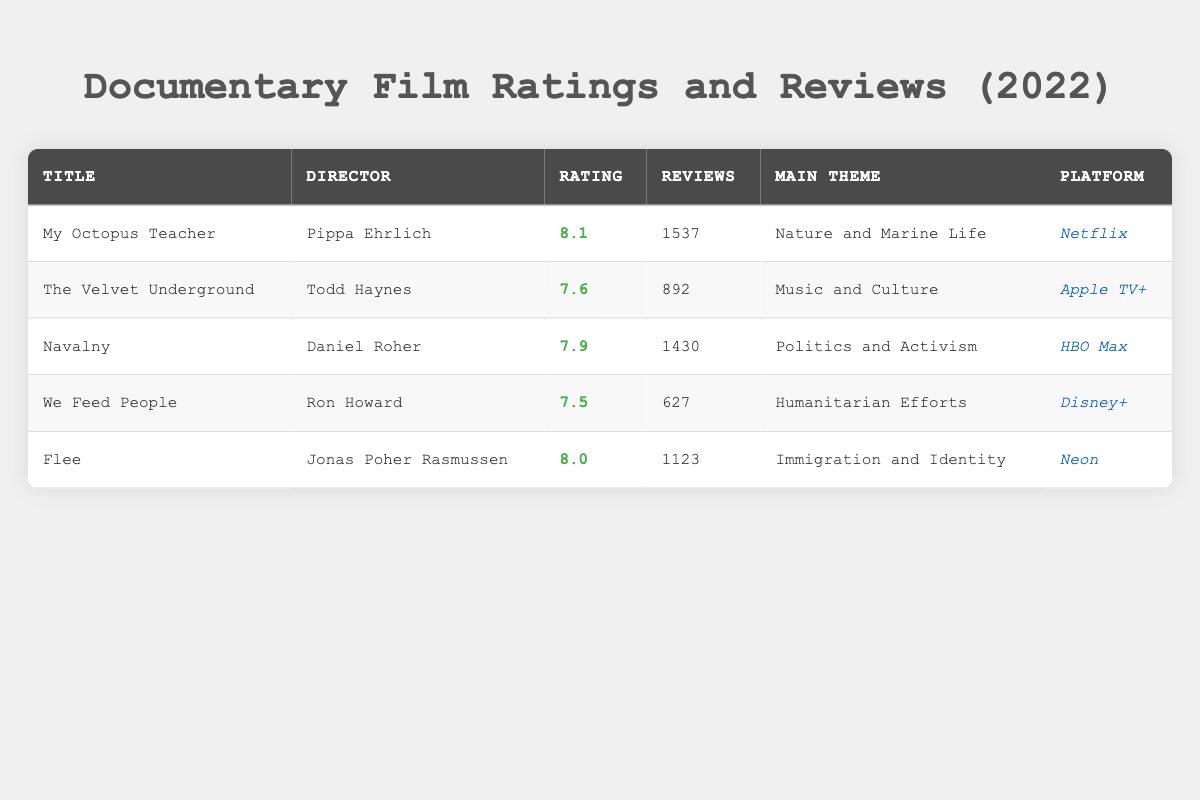What is the highest rated documentary in 2022 according to the table? The table lists several documentaries with their ratings. By checking the ratings, "My Octopus Teacher" has the highest rating of 8.1.
Answer: My Octopus Teacher How many reviews did Flee receive? The title "Flee" has 1123 reviews listed in the table.
Answer: 1123 Which documentary has the main theme of "Politics and Activism"? By looking at the table, we can see that "Navalny" has the main theme of "Politics and Activism."
Answer: Navalny What is the average rating of the documentaries listed? To find the average rating, sum the ratings: 8.1 + 7.6 + 7.9 + 7.5 + 8.0 = 39.1. There are 5 documentaries, so the average rating is 39.1 / 5 = 7.82.
Answer: 7.82 Is there a documentary directed by Pippa Ehrlich? The table shows that "My Octopus Teacher" is directed by Pippa Ehrlich. Therefore, the answer is yes.
Answer: Yes Which platform has the least number of reviews for its documentary? Looking at the reviews counts of each documentary: Netflix (1537), Apple TV+ (892), HBO Max (1430), Disney+ (627), and Neon (1123). The least is 627, which is on Disney+.
Answer: Disney+ How many documentaries have a rating of 8.0 or higher? The documentaries with ratings of 8.0 or higher are "My Octopus Teacher" (8.1) and "Flee" (8.0). Adding these, there are 2 documentaries in total.
Answer: 2 What is the total number of reviews across all documentaries? Adding the reviews together: 1537 + 892 + 1430 + 627 + 1123 = 4609. This is the total number of reviews for all documentaries listed.
Answer: 4609 Is "We Feed People" available on HBO Max? The table shows that "We Feed People" is on Disney+, not HBO Max, therefore the answer is no.
Answer: No 